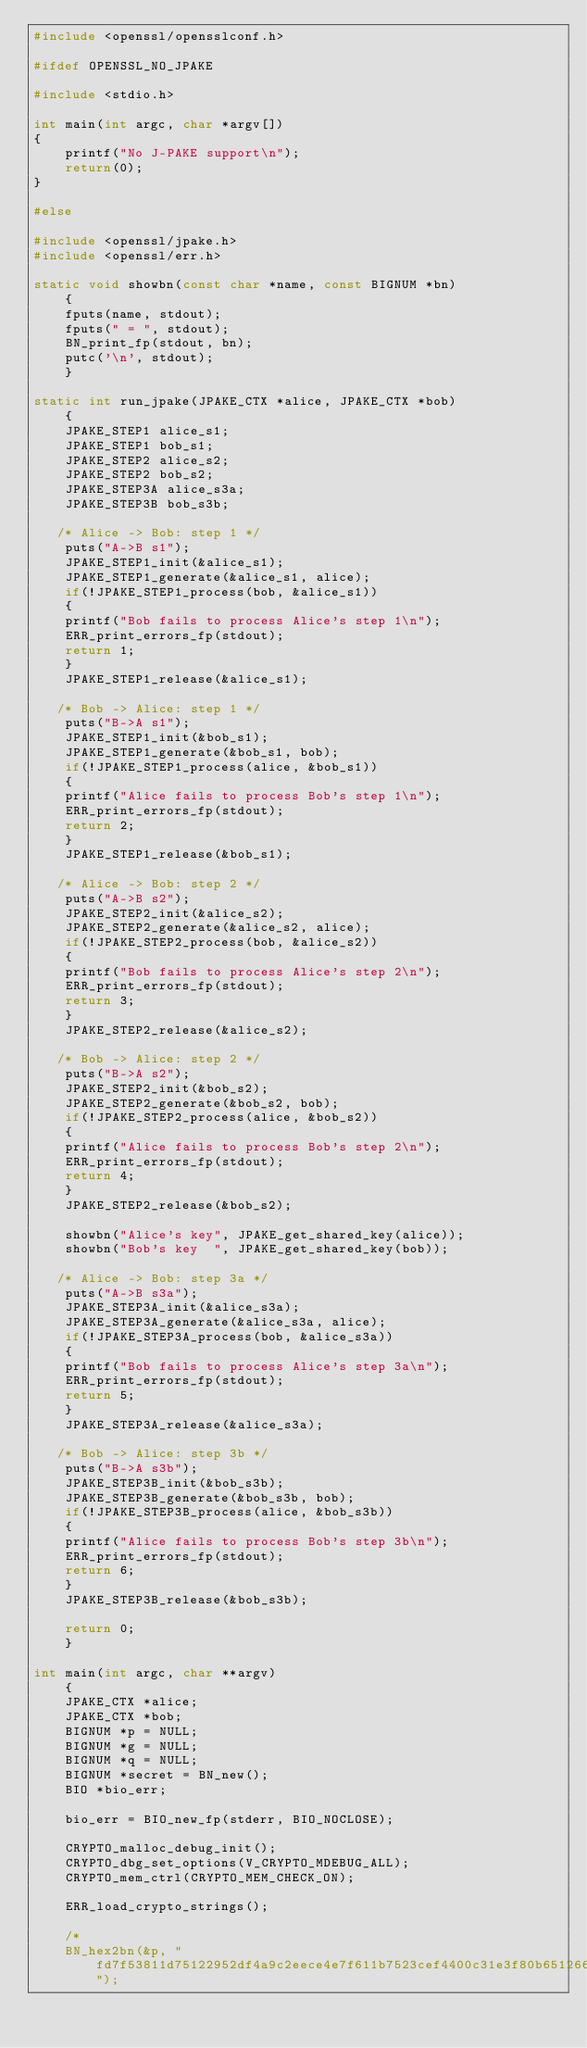Convert code to text. <code><loc_0><loc_0><loc_500><loc_500><_C_>#include <openssl/opensslconf.h>

#ifdef OPENSSL_NO_JPAKE

#include <stdio.h>

int main(int argc, char *argv[])
{
    printf("No J-PAKE support\n");
    return(0);
}

#else

#include <openssl/jpake.h>
#include <openssl/err.h>

static void showbn(const char *name, const BIGNUM *bn)
    {
    fputs(name, stdout);
    fputs(" = ", stdout);
    BN_print_fp(stdout, bn);
    putc('\n', stdout);
    }

static int run_jpake(JPAKE_CTX *alice, JPAKE_CTX *bob)
    {
    JPAKE_STEP1 alice_s1;
    JPAKE_STEP1 bob_s1;
    JPAKE_STEP2 alice_s2;
    JPAKE_STEP2 bob_s2;
    JPAKE_STEP3A alice_s3a;
    JPAKE_STEP3B bob_s3b;

   /* Alice -> Bob: step 1 */
    puts("A->B s1");
    JPAKE_STEP1_init(&alice_s1);
    JPAKE_STEP1_generate(&alice_s1, alice);
    if(!JPAKE_STEP1_process(bob, &alice_s1))
	{
	printf("Bob fails to process Alice's step 1\n");
	ERR_print_errors_fp(stdout);
	return 1;
	}
    JPAKE_STEP1_release(&alice_s1);

   /* Bob -> Alice: step 1 */
    puts("B->A s1");
    JPAKE_STEP1_init(&bob_s1);
    JPAKE_STEP1_generate(&bob_s1, bob);
    if(!JPAKE_STEP1_process(alice, &bob_s1))
	{
	printf("Alice fails to process Bob's step 1\n");
	ERR_print_errors_fp(stdout);
	return 2;
	}
    JPAKE_STEP1_release(&bob_s1);

   /* Alice -> Bob: step 2 */
    puts("A->B s2");
    JPAKE_STEP2_init(&alice_s2);
    JPAKE_STEP2_generate(&alice_s2, alice);
    if(!JPAKE_STEP2_process(bob, &alice_s2))
	{
	printf("Bob fails to process Alice's step 2\n");
	ERR_print_errors_fp(stdout);
	return 3;
	}
    JPAKE_STEP2_release(&alice_s2);

   /* Bob -> Alice: step 2 */
    puts("B->A s2");
    JPAKE_STEP2_init(&bob_s2);
    JPAKE_STEP2_generate(&bob_s2, bob);
    if(!JPAKE_STEP2_process(alice, &bob_s2))
	{
	printf("Alice fails to process Bob's step 2\n");
	ERR_print_errors_fp(stdout);
	return 4;
	}
    JPAKE_STEP2_release(&bob_s2);

    showbn("Alice's key", JPAKE_get_shared_key(alice));
    showbn("Bob's key  ", JPAKE_get_shared_key(bob));

   /* Alice -> Bob: step 3a */
    puts("A->B s3a");
    JPAKE_STEP3A_init(&alice_s3a);
    JPAKE_STEP3A_generate(&alice_s3a, alice);
    if(!JPAKE_STEP3A_process(bob, &alice_s3a))
	{
	printf("Bob fails to process Alice's step 3a\n");
	ERR_print_errors_fp(stdout);
	return 5;
	}
    JPAKE_STEP3A_release(&alice_s3a);
    
   /* Bob -> Alice: step 3b */
    puts("B->A s3b");
    JPAKE_STEP3B_init(&bob_s3b);
    JPAKE_STEP3B_generate(&bob_s3b, bob);
    if(!JPAKE_STEP3B_process(alice, &bob_s3b))
	{
	printf("Alice fails to process Bob's step 3b\n");
	ERR_print_errors_fp(stdout);
	return 6;
	}
    JPAKE_STEP3B_release(&bob_s3b);

    return 0;
    }

int main(int argc, char **argv)
    {
    JPAKE_CTX *alice;
    JPAKE_CTX *bob;
    BIGNUM *p = NULL;
    BIGNUM *g = NULL;
    BIGNUM *q = NULL;
    BIGNUM *secret = BN_new();
    BIO *bio_err;

    bio_err = BIO_new_fp(stderr, BIO_NOCLOSE);

    CRYPTO_malloc_debug_init();
    CRYPTO_dbg_set_options(V_CRYPTO_MDEBUG_ALL);
    CRYPTO_mem_ctrl(CRYPTO_MEM_CHECK_ON);

    ERR_load_crypto_strings();

    /*
    BN_hex2bn(&p, "fd7f53811d75122952df4a9c2eece4e7f611b7523cef4400c31e3f80b6512669455d402251fb593d8d58fabfc5f5ba30f6cb9b556cd7813b801d346ff26660b76b9950a5a49f9fe8047b1022c24fbba9d7feb7c61bf83b57e7c6a8a6150f04fb83f6d3c51ec3023554135a169132f675f3ae2b61d72aeff22203199dd14801c7");</code> 